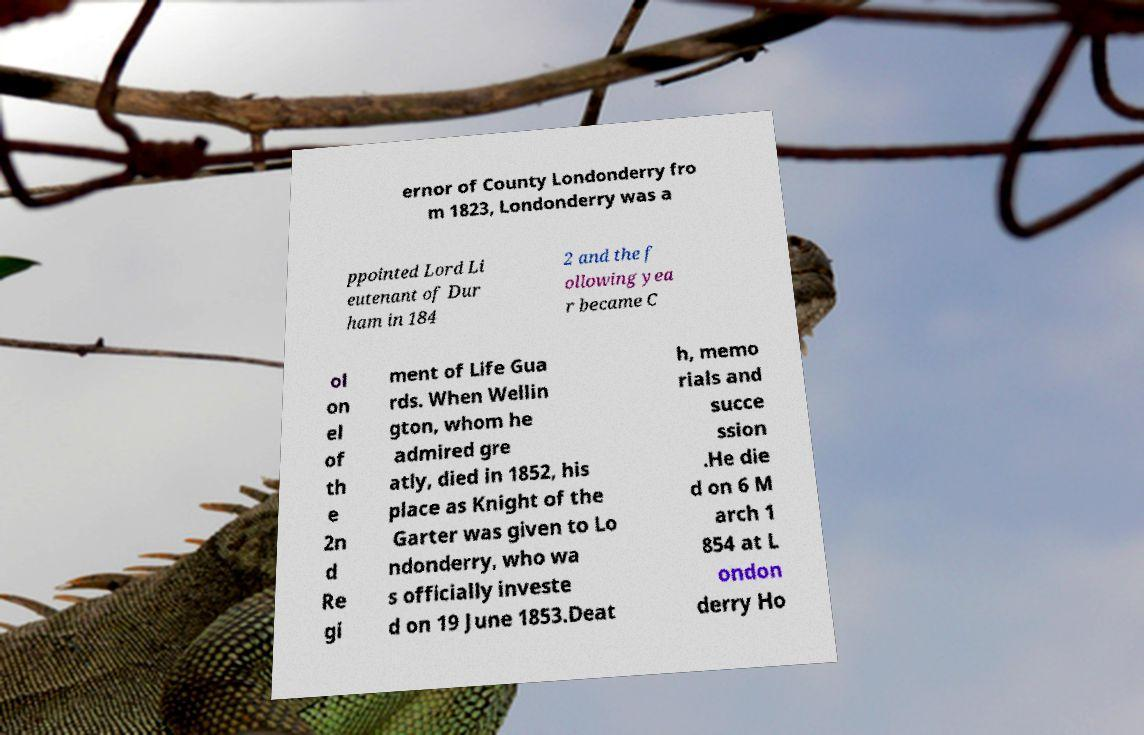Can you accurately transcribe the text from the provided image for me? ernor of County Londonderry fro m 1823, Londonderry was a ppointed Lord Li eutenant of Dur ham in 184 2 and the f ollowing yea r became C ol on el of th e 2n d Re gi ment of Life Gua rds. When Wellin gton, whom he admired gre atly, died in 1852, his place as Knight of the Garter was given to Lo ndonderry, who wa s officially investe d on 19 June 1853.Deat h, memo rials and succe ssion .He die d on 6 M arch 1 854 at L ondon derry Ho 